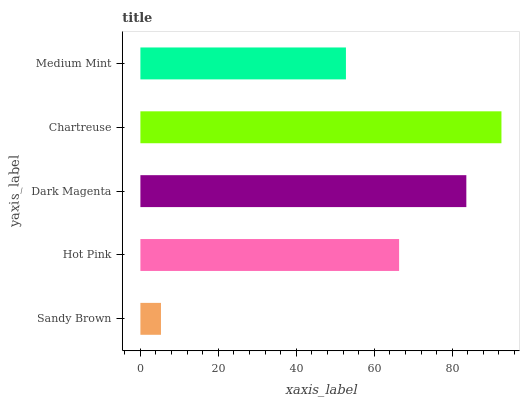Is Sandy Brown the minimum?
Answer yes or no. Yes. Is Chartreuse the maximum?
Answer yes or no. Yes. Is Hot Pink the minimum?
Answer yes or no. No. Is Hot Pink the maximum?
Answer yes or no. No. Is Hot Pink greater than Sandy Brown?
Answer yes or no. Yes. Is Sandy Brown less than Hot Pink?
Answer yes or no. Yes. Is Sandy Brown greater than Hot Pink?
Answer yes or no. No. Is Hot Pink less than Sandy Brown?
Answer yes or no. No. Is Hot Pink the high median?
Answer yes or no. Yes. Is Hot Pink the low median?
Answer yes or no. Yes. Is Dark Magenta the high median?
Answer yes or no. No. Is Sandy Brown the low median?
Answer yes or no. No. 